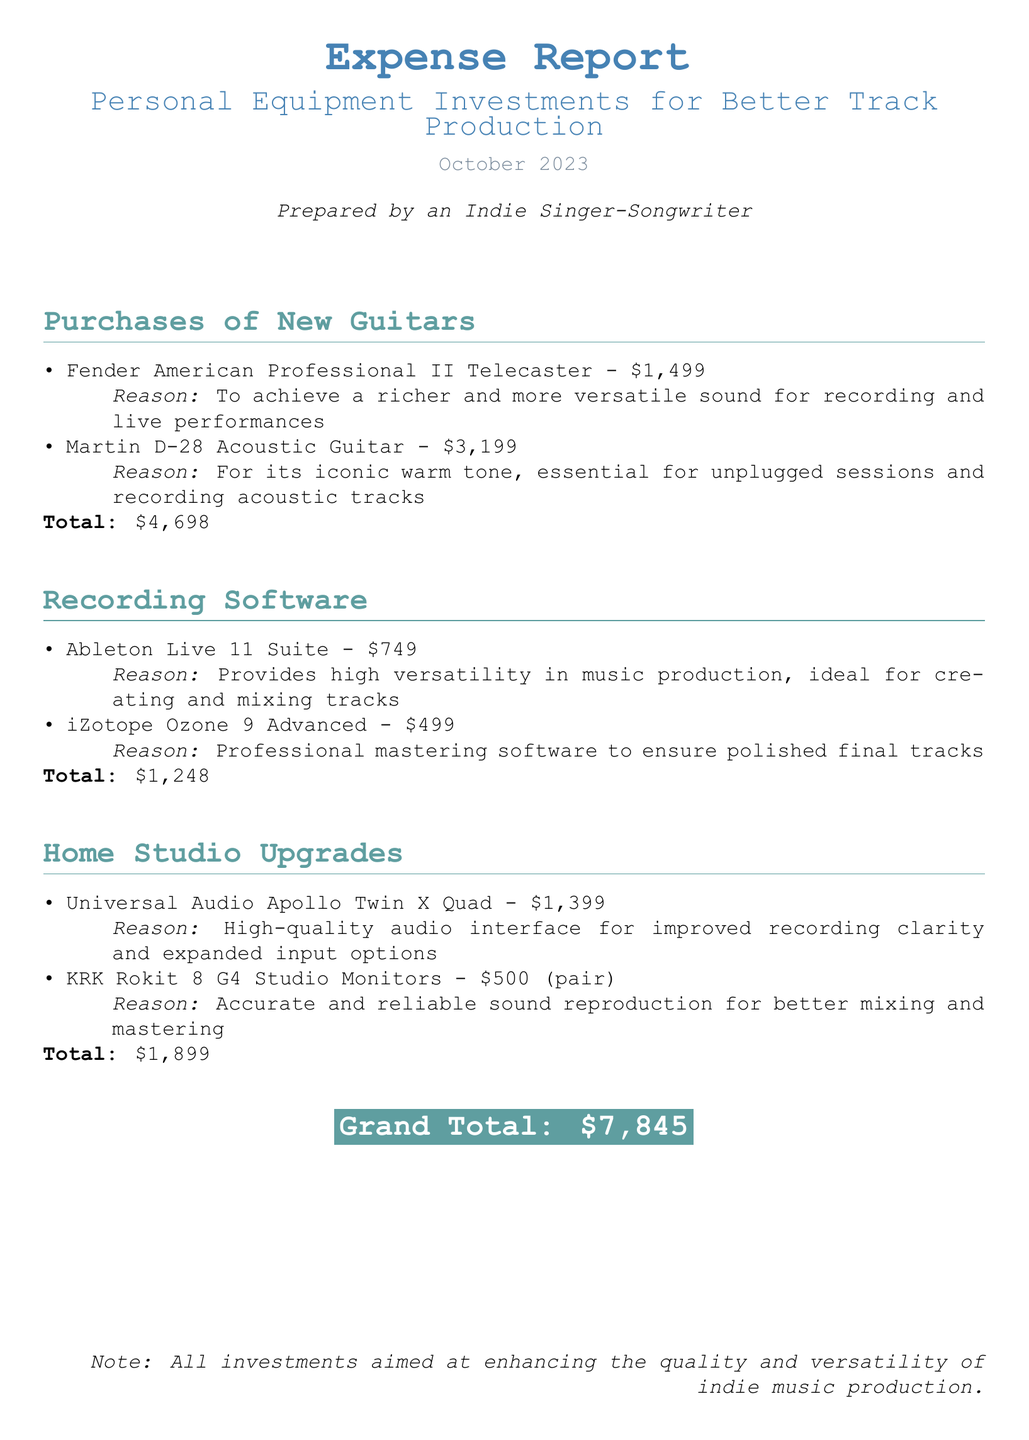What is the total amount spent on new guitars? The total amount for new guitars is the sum of the prices of the Fender American Professional II Telecaster and the Martin D-28 Acoustic Guitar, which is $1,499 + $3,199 = $4,698.
Answer: $4,698 What is the price of Ableton Live 11 Suite? The document specifies that Ableton Live 11 Suite costs $749.
Answer: $749 What reason is given for purchasing the Martin D-28 Acoustic Guitar? The document states that the reason for purchasing the Martin D-28 Acoustic Guitar is its iconic warm tone, essential for unplugged sessions and recording acoustic tracks.
Answer: For its iconic warm tone, essential for unplugged sessions and recording acoustic tracks How much do the KRK Rokit 8 G4 Studio Monitors cost? The document indicates that the cost for a pair of KRK Rokit 8 G4 Studio Monitors is $500.
Answer: $500 What is the grand total of all expenses listed? The grand total, which aggregates all purchases in the report, is $7,845.
Answer: $7,845 Which recording software is mentioned as professional mastering software? The document identifies iZotope Ozone 9 Advanced as the professional mastering software.
Answer: iZotope Ozone 9 Advanced What is the main purpose of the investments listed in the document? The note at the end states that all investments are aimed at enhancing the quality and versatility of indie music production.
Answer: Enhancing the quality and versatility of indie music production How many new guitars were purchased according to the report? The document lists two new guitars that were purchased.
Answer: Two 